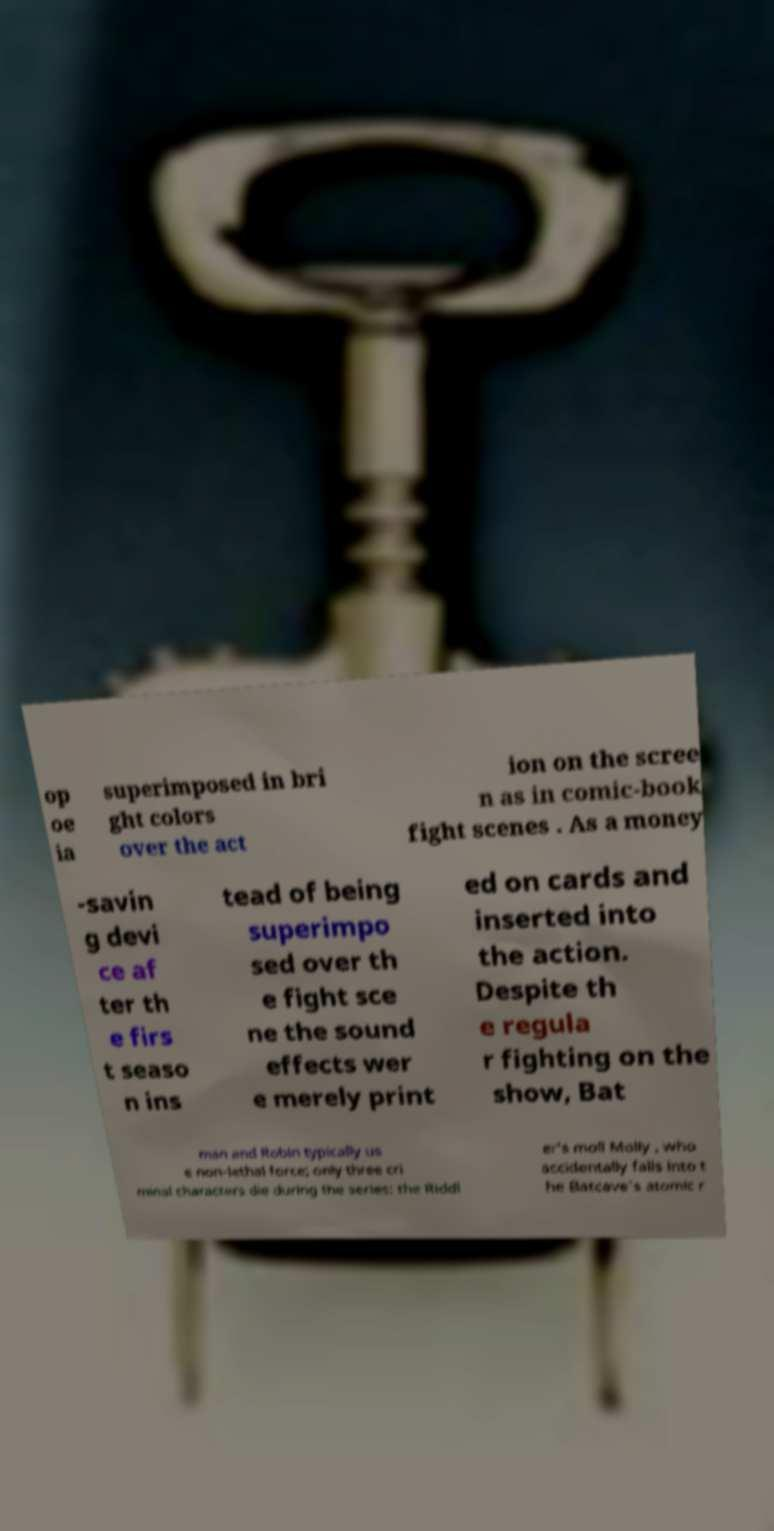I need the written content from this picture converted into text. Can you do that? op oe ia superimposed in bri ght colors over the act ion on the scree n as in comic-book fight scenes . As a money -savin g devi ce af ter th e firs t seaso n ins tead of being superimpo sed over th e fight sce ne the sound effects wer e merely print ed on cards and inserted into the action. Despite th e regula r fighting on the show, Bat man and Robin typically us e non-lethal force; only three cri minal characters die during the series: the Riddl er's moll Molly , who accidentally falls into t he Batcave's atomic r 